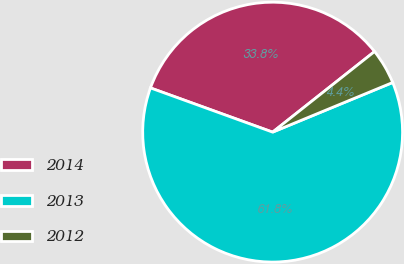<chart> <loc_0><loc_0><loc_500><loc_500><pie_chart><fcel>2014<fcel>2013<fcel>2012<nl><fcel>33.82%<fcel>61.76%<fcel>4.41%<nl></chart> 